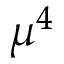Convert formula to latex. <formula><loc_0><loc_0><loc_500><loc_500>\mu ^ { 4 }</formula> 